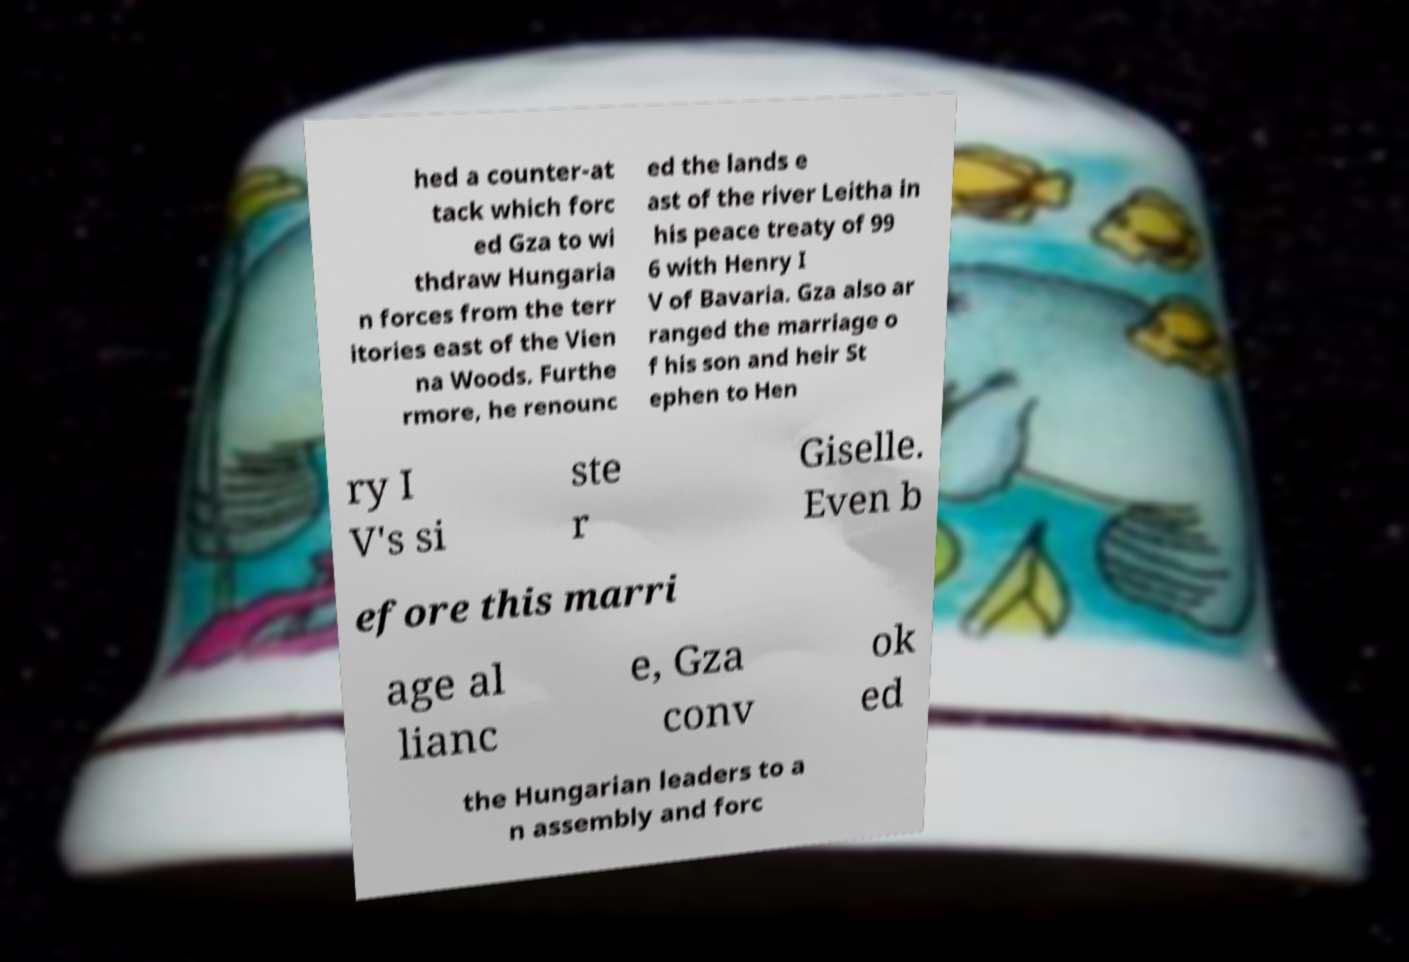There's text embedded in this image that I need extracted. Can you transcribe it verbatim? hed a counter-at tack which forc ed Gza to wi thdraw Hungaria n forces from the terr itories east of the Vien na Woods. Furthe rmore, he renounc ed the lands e ast of the river Leitha in his peace treaty of 99 6 with Henry I V of Bavaria. Gza also ar ranged the marriage o f his son and heir St ephen to Hen ry I V's si ste r Giselle. Even b efore this marri age al lianc e, Gza conv ok ed the Hungarian leaders to a n assembly and forc 